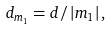<formula> <loc_0><loc_0><loc_500><loc_500>d _ { m _ { 1 } } = d / \left | m _ { 1 } \right | ,</formula> 